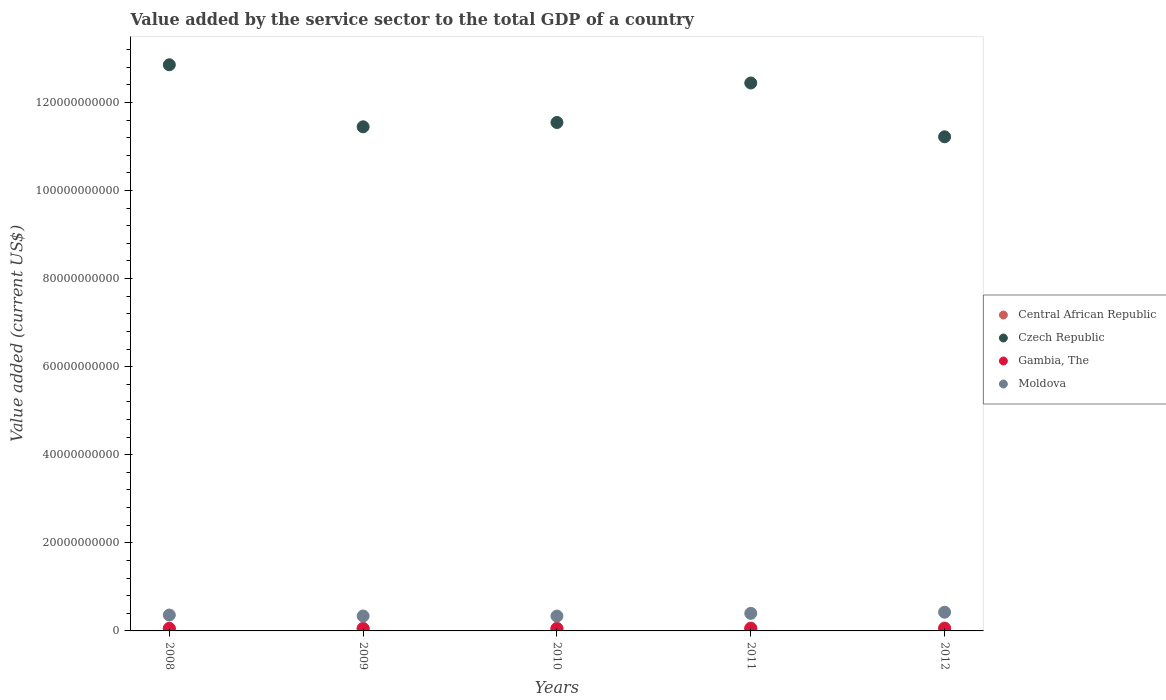How many different coloured dotlines are there?
Keep it short and to the point. 4. What is the value added by the service sector to the total GDP in Czech Republic in 2009?
Provide a short and direct response. 1.14e+11. Across all years, what is the maximum value added by the service sector to the total GDP in Czech Republic?
Give a very brief answer. 1.29e+11. Across all years, what is the minimum value added by the service sector to the total GDP in Czech Republic?
Your answer should be compact. 1.12e+11. In which year was the value added by the service sector to the total GDP in Central African Republic minimum?
Offer a very short reply. 2008. What is the total value added by the service sector to the total GDP in Gambia, The in the graph?
Offer a terse response. 2.60e+09. What is the difference between the value added by the service sector to the total GDP in Czech Republic in 2010 and that in 2012?
Keep it short and to the point. 3.25e+09. What is the difference between the value added by the service sector to the total GDP in Moldova in 2009 and the value added by the service sector to the total GDP in Central African Republic in 2008?
Ensure brevity in your answer.  2.81e+09. What is the average value added by the service sector to the total GDP in Czech Republic per year?
Provide a short and direct response. 1.19e+11. In the year 2011, what is the difference between the value added by the service sector to the total GDP in Gambia, The and value added by the service sector to the total GDP in Central African Republic?
Provide a succinct answer. -1.29e+08. In how many years, is the value added by the service sector to the total GDP in Central African Republic greater than 28000000000 US$?
Make the answer very short. 0. What is the ratio of the value added by the service sector to the total GDP in Central African Republic in 2008 to that in 2009?
Make the answer very short. 0.99. Is the difference between the value added by the service sector to the total GDP in Gambia, The in 2008 and 2009 greater than the difference between the value added by the service sector to the total GDP in Central African Republic in 2008 and 2009?
Make the answer very short. Yes. What is the difference between the highest and the second highest value added by the service sector to the total GDP in Gambia, The?
Give a very brief answer. 7.05e+06. What is the difference between the highest and the lowest value added by the service sector to the total GDP in Gambia, The?
Give a very brief answer. 4.17e+07. Is it the case that in every year, the sum of the value added by the service sector to the total GDP in Moldova and value added by the service sector to the total GDP in Gambia, The  is greater than the value added by the service sector to the total GDP in Czech Republic?
Make the answer very short. No. Is the value added by the service sector to the total GDP in Central African Republic strictly greater than the value added by the service sector to the total GDP in Moldova over the years?
Offer a very short reply. No. Is the value added by the service sector to the total GDP in Moldova strictly less than the value added by the service sector to the total GDP in Gambia, The over the years?
Ensure brevity in your answer.  No. How many dotlines are there?
Ensure brevity in your answer.  4. What is the difference between two consecutive major ticks on the Y-axis?
Ensure brevity in your answer.  2.00e+1. Where does the legend appear in the graph?
Make the answer very short. Center right. How many legend labels are there?
Your answer should be compact. 4. How are the legend labels stacked?
Your answer should be compact. Vertical. What is the title of the graph?
Offer a very short reply. Value added by the service sector to the total GDP of a country. What is the label or title of the Y-axis?
Keep it short and to the point. Value added (current US$). What is the Value added (current US$) in Central African Republic in 2008?
Ensure brevity in your answer.  5.79e+08. What is the Value added (current US$) of Czech Republic in 2008?
Make the answer very short. 1.29e+11. What is the Value added (current US$) in Gambia, The in 2008?
Offer a terse response. 5.37e+08. What is the Value added (current US$) of Moldova in 2008?
Your response must be concise. 3.61e+09. What is the Value added (current US$) of Central African Republic in 2009?
Offer a very short reply. 5.87e+08. What is the Value added (current US$) in Czech Republic in 2009?
Your answer should be compact. 1.14e+11. What is the Value added (current US$) of Gambia, The in 2009?
Offer a terse response. 4.95e+08. What is the Value added (current US$) in Moldova in 2009?
Offer a very short reply. 3.39e+09. What is the Value added (current US$) of Central African Republic in 2010?
Provide a succinct answer. 5.90e+08. What is the Value added (current US$) of Czech Republic in 2010?
Provide a succinct answer. 1.15e+11. What is the Value added (current US$) in Gambia, The in 2010?
Give a very brief answer. 5.06e+08. What is the Value added (current US$) in Moldova in 2010?
Provide a short and direct response. 3.37e+09. What is the Value added (current US$) in Central African Republic in 2011?
Give a very brief answer. 6.57e+08. What is the Value added (current US$) in Czech Republic in 2011?
Keep it short and to the point. 1.24e+11. What is the Value added (current US$) of Gambia, The in 2011?
Keep it short and to the point. 5.28e+08. What is the Value added (current US$) of Moldova in 2011?
Your answer should be compact. 3.98e+09. What is the Value added (current US$) of Central African Republic in 2012?
Your answer should be very brief. 6.59e+08. What is the Value added (current US$) of Czech Republic in 2012?
Make the answer very short. 1.12e+11. What is the Value added (current US$) of Gambia, The in 2012?
Give a very brief answer. 5.30e+08. What is the Value added (current US$) of Moldova in 2012?
Your answer should be compact. 4.25e+09. Across all years, what is the maximum Value added (current US$) in Central African Republic?
Offer a very short reply. 6.59e+08. Across all years, what is the maximum Value added (current US$) of Czech Republic?
Your answer should be compact. 1.29e+11. Across all years, what is the maximum Value added (current US$) of Gambia, The?
Provide a succinct answer. 5.37e+08. Across all years, what is the maximum Value added (current US$) in Moldova?
Keep it short and to the point. 4.25e+09. Across all years, what is the minimum Value added (current US$) in Central African Republic?
Offer a terse response. 5.79e+08. Across all years, what is the minimum Value added (current US$) in Czech Republic?
Provide a succinct answer. 1.12e+11. Across all years, what is the minimum Value added (current US$) in Gambia, The?
Ensure brevity in your answer.  4.95e+08. Across all years, what is the minimum Value added (current US$) in Moldova?
Your answer should be compact. 3.37e+09. What is the total Value added (current US$) of Central African Republic in the graph?
Provide a succinct answer. 3.07e+09. What is the total Value added (current US$) of Czech Republic in the graph?
Keep it short and to the point. 5.95e+11. What is the total Value added (current US$) in Gambia, The in the graph?
Your response must be concise. 2.60e+09. What is the total Value added (current US$) in Moldova in the graph?
Offer a very short reply. 1.86e+1. What is the difference between the Value added (current US$) of Central African Republic in 2008 and that in 2009?
Offer a very short reply. -7.69e+06. What is the difference between the Value added (current US$) of Czech Republic in 2008 and that in 2009?
Your answer should be compact. 1.41e+1. What is the difference between the Value added (current US$) in Gambia, The in 2008 and that in 2009?
Your answer should be very brief. 4.17e+07. What is the difference between the Value added (current US$) of Moldova in 2008 and that in 2009?
Provide a succinct answer. 2.19e+08. What is the difference between the Value added (current US$) in Central African Republic in 2008 and that in 2010?
Ensure brevity in your answer.  -1.05e+07. What is the difference between the Value added (current US$) in Czech Republic in 2008 and that in 2010?
Keep it short and to the point. 1.31e+1. What is the difference between the Value added (current US$) in Gambia, The in 2008 and that in 2010?
Give a very brief answer. 3.08e+07. What is the difference between the Value added (current US$) in Moldova in 2008 and that in 2010?
Your answer should be compact. 2.34e+08. What is the difference between the Value added (current US$) in Central African Republic in 2008 and that in 2011?
Offer a terse response. -7.82e+07. What is the difference between the Value added (current US$) in Czech Republic in 2008 and that in 2011?
Offer a terse response. 4.14e+09. What is the difference between the Value added (current US$) in Gambia, The in 2008 and that in 2011?
Provide a short and direct response. 8.90e+06. What is the difference between the Value added (current US$) in Moldova in 2008 and that in 2011?
Ensure brevity in your answer.  -3.77e+08. What is the difference between the Value added (current US$) of Central African Republic in 2008 and that in 2012?
Provide a short and direct response. -7.96e+07. What is the difference between the Value added (current US$) in Czech Republic in 2008 and that in 2012?
Your response must be concise. 1.64e+1. What is the difference between the Value added (current US$) in Gambia, The in 2008 and that in 2012?
Your answer should be very brief. 7.05e+06. What is the difference between the Value added (current US$) of Moldova in 2008 and that in 2012?
Give a very brief answer. -6.42e+08. What is the difference between the Value added (current US$) of Central African Republic in 2009 and that in 2010?
Provide a short and direct response. -2.83e+06. What is the difference between the Value added (current US$) in Czech Republic in 2009 and that in 2010?
Ensure brevity in your answer.  -9.76e+08. What is the difference between the Value added (current US$) of Gambia, The in 2009 and that in 2010?
Provide a succinct answer. -1.09e+07. What is the difference between the Value added (current US$) in Moldova in 2009 and that in 2010?
Your answer should be very brief. 1.49e+07. What is the difference between the Value added (current US$) in Central African Republic in 2009 and that in 2011?
Keep it short and to the point. -7.05e+07. What is the difference between the Value added (current US$) of Czech Republic in 2009 and that in 2011?
Your answer should be compact. -9.95e+09. What is the difference between the Value added (current US$) of Gambia, The in 2009 and that in 2011?
Make the answer very short. -3.28e+07. What is the difference between the Value added (current US$) in Moldova in 2009 and that in 2011?
Provide a succinct answer. -5.96e+08. What is the difference between the Value added (current US$) in Central African Republic in 2009 and that in 2012?
Offer a very short reply. -7.19e+07. What is the difference between the Value added (current US$) in Czech Republic in 2009 and that in 2012?
Make the answer very short. 2.27e+09. What is the difference between the Value added (current US$) of Gambia, The in 2009 and that in 2012?
Your response must be concise. -3.47e+07. What is the difference between the Value added (current US$) of Moldova in 2009 and that in 2012?
Your response must be concise. -8.62e+08. What is the difference between the Value added (current US$) of Central African Republic in 2010 and that in 2011?
Offer a terse response. -6.77e+07. What is the difference between the Value added (current US$) of Czech Republic in 2010 and that in 2011?
Provide a succinct answer. -8.97e+09. What is the difference between the Value added (current US$) in Gambia, The in 2010 and that in 2011?
Provide a short and direct response. -2.19e+07. What is the difference between the Value added (current US$) in Moldova in 2010 and that in 2011?
Provide a succinct answer. -6.11e+08. What is the difference between the Value added (current US$) in Central African Republic in 2010 and that in 2012?
Keep it short and to the point. -6.91e+07. What is the difference between the Value added (current US$) in Czech Republic in 2010 and that in 2012?
Make the answer very short. 3.25e+09. What is the difference between the Value added (current US$) of Gambia, The in 2010 and that in 2012?
Make the answer very short. -2.37e+07. What is the difference between the Value added (current US$) of Moldova in 2010 and that in 2012?
Your answer should be compact. -8.77e+08. What is the difference between the Value added (current US$) in Central African Republic in 2011 and that in 2012?
Offer a very short reply. -1.39e+06. What is the difference between the Value added (current US$) in Czech Republic in 2011 and that in 2012?
Your answer should be very brief. 1.22e+1. What is the difference between the Value added (current US$) in Gambia, The in 2011 and that in 2012?
Your answer should be compact. -1.85e+06. What is the difference between the Value added (current US$) in Moldova in 2011 and that in 2012?
Ensure brevity in your answer.  -2.65e+08. What is the difference between the Value added (current US$) of Central African Republic in 2008 and the Value added (current US$) of Czech Republic in 2009?
Offer a very short reply. -1.14e+11. What is the difference between the Value added (current US$) of Central African Republic in 2008 and the Value added (current US$) of Gambia, The in 2009?
Keep it short and to the point. 8.40e+07. What is the difference between the Value added (current US$) in Central African Republic in 2008 and the Value added (current US$) in Moldova in 2009?
Keep it short and to the point. -2.81e+09. What is the difference between the Value added (current US$) in Czech Republic in 2008 and the Value added (current US$) in Gambia, The in 2009?
Provide a short and direct response. 1.28e+11. What is the difference between the Value added (current US$) of Czech Republic in 2008 and the Value added (current US$) of Moldova in 2009?
Provide a short and direct response. 1.25e+11. What is the difference between the Value added (current US$) in Gambia, The in 2008 and the Value added (current US$) in Moldova in 2009?
Provide a short and direct response. -2.85e+09. What is the difference between the Value added (current US$) of Central African Republic in 2008 and the Value added (current US$) of Czech Republic in 2010?
Provide a succinct answer. -1.15e+11. What is the difference between the Value added (current US$) in Central African Republic in 2008 and the Value added (current US$) in Gambia, The in 2010?
Your answer should be compact. 7.31e+07. What is the difference between the Value added (current US$) of Central African Republic in 2008 and the Value added (current US$) of Moldova in 2010?
Make the answer very short. -2.79e+09. What is the difference between the Value added (current US$) in Czech Republic in 2008 and the Value added (current US$) in Gambia, The in 2010?
Ensure brevity in your answer.  1.28e+11. What is the difference between the Value added (current US$) in Czech Republic in 2008 and the Value added (current US$) in Moldova in 2010?
Your answer should be compact. 1.25e+11. What is the difference between the Value added (current US$) in Gambia, The in 2008 and the Value added (current US$) in Moldova in 2010?
Your response must be concise. -2.84e+09. What is the difference between the Value added (current US$) of Central African Republic in 2008 and the Value added (current US$) of Czech Republic in 2011?
Offer a very short reply. -1.24e+11. What is the difference between the Value added (current US$) in Central African Republic in 2008 and the Value added (current US$) in Gambia, The in 2011?
Offer a very short reply. 5.12e+07. What is the difference between the Value added (current US$) of Central African Republic in 2008 and the Value added (current US$) of Moldova in 2011?
Give a very brief answer. -3.41e+09. What is the difference between the Value added (current US$) of Czech Republic in 2008 and the Value added (current US$) of Gambia, The in 2011?
Keep it short and to the point. 1.28e+11. What is the difference between the Value added (current US$) of Czech Republic in 2008 and the Value added (current US$) of Moldova in 2011?
Offer a terse response. 1.25e+11. What is the difference between the Value added (current US$) of Gambia, The in 2008 and the Value added (current US$) of Moldova in 2011?
Keep it short and to the point. -3.45e+09. What is the difference between the Value added (current US$) in Central African Republic in 2008 and the Value added (current US$) in Czech Republic in 2012?
Your answer should be very brief. -1.12e+11. What is the difference between the Value added (current US$) of Central African Republic in 2008 and the Value added (current US$) of Gambia, The in 2012?
Your answer should be compact. 4.93e+07. What is the difference between the Value added (current US$) of Central African Republic in 2008 and the Value added (current US$) of Moldova in 2012?
Ensure brevity in your answer.  -3.67e+09. What is the difference between the Value added (current US$) in Czech Republic in 2008 and the Value added (current US$) in Gambia, The in 2012?
Make the answer very short. 1.28e+11. What is the difference between the Value added (current US$) in Czech Republic in 2008 and the Value added (current US$) in Moldova in 2012?
Provide a succinct answer. 1.24e+11. What is the difference between the Value added (current US$) in Gambia, The in 2008 and the Value added (current US$) in Moldova in 2012?
Give a very brief answer. -3.71e+09. What is the difference between the Value added (current US$) of Central African Republic in 2009 and the Value added (current US$) of Czech Republic in 2010?
Ensure brevity in your answer.  -1.15e+11. What is the difference between the Value added (current US$) of Central African Republic in 2009 and the Value added (current US$) of Gambia, The in 2010?
Your response must be concise. 8.08e+07. What is the difference between the Value added (current US$) in Central African Republic in 2009 and the Value added (current US$) in Moldova in 2010?
Provide a succinct answer. -2.79e+09. What is the difference between the Value added (current US$) of Czech Republic in 2009 and the Value added (current US$) of Gambia, The in 2010?
Offer a very short reply. 1.14e+11. What is the difference between the Value added (current US$) of Czech Republic in 2009 and the Value added (current US$) of Moldova in 2010?
Ensure brevity in your answer.  1.11e+11. What is the difference between the Value added (current US$) of Gambia, The in 2009 and the Value added (current US$) of Moldova in 2010?
Keep it short and to the point. -2.88e+09. What is the difference between the Value added (current US$) of Central African Republic in 2009 and the Value added (current US$) of Czech Republic in 2011?
Ensure brevity in your answer.  -1.24e+11. What is the difference between the Value added (current US$) in Central African Republic in 2009 and the Value added (current US$) in Gambia, The in 2011?
Offer a very short reply. 5.89e+07. What is the difference between the Value added (current US$) in Central African Republic in 2009 and the Value added (current US$) in Moldova in 2011?
Make the answer very short. -3.40e+09. What is the difference between the Value added (current US$) in Czech Republic in 2009 and the Value added (current US$) in Gambia, The in 2011?
Provide a succinct answer. 1.14e+11. What is the difference between the Value added (current US$) of Czech Republic in 2009 and the Value added (current US$) of Moldova in 2011?
Your response must be concise. 1.10e+11. What is the difference between the Value added (current US$) of Gambia, The in 2009 and the Value added (current US$) of Moldova in 2011?
Offer a very short reply. -3.49e+09. What is the difference between the Value added (current US$) in Central African Republic in 2009 and the Value added (current US$) in Czech Republic in 2012?
Provide a succinct answer. -1.12e+11. What is the difference between the Value added (current US$) of Central African Republic in 2009 and the Value added (current US$) of Gambia, The in 2012?
Provide a succinct answer. 5.70e+07. What is the difference between the Value added (current US$) in Central African Republic in 2009 and the Value added (current US$) in Moldova in 2012?
Provide a short and direct response. -3.66e+09. What is the difference between the Value added (current US$) of Czech Republic in 2009 and the Value added (current US$) of Gambia, The in 2012?
Ensure brevity in your answer.  1.14e+11. What is the difference between the Value added (current US$) in Czech Republic in 2009 and the Value added (current US$) in Moldova in 2012?
Ensure brevity in your answer.  1.10e+11. What is the difference between the Value added (current US$) in Gambia, The in 2009 and the Value added (current US$) in Moldova in 2012?
Provide a short and direct response. -3.76e+09. What is the difference between the Value added (current US$) of Central African Republic in 2010 and the Value added (current US$) of Czech Republic in 2011?
Make the answer very short. -1.24e+11. What is the difference between the Value added (current US$) of Central African Republic in 2010 and the Value added (current US$) of Gambia, The in 2011?
Your answer should be compact. 6.17e+07. What is the difference between the Value added (current US$) in Central African Republic in 2010 and the Value added (current US$) in Moldova in 2011?
Offer a terse response. -3.40e+09. What is the difference between the Value added (current US$) in Czech Republic in 2010 and the Value added (current US$) in Gambia, The in 2011?
Your response must be concise. 1.15e+11. What is the difference between the Value added (current US$) in Czech Republic in 2010 and the Value added (current US$) in Moldova in 2011?
Your answer should be compact. 1.11e+11. What is the difference between the Value added (current US$) in Gambia, The in 2010 and the Value added (current US$) in Moldova in 2011?
Make the answer very short. -3.48e+09. What is the difference between the Value added (current US$) in Central African Republic in 2010 and the Value added (current US$) in Czech Republic in 2012?
Your answer should be compact. -1.12e+11. What is the difference between the Value added (current US$) of Central African Republic in 2010 and the Value added (current US$) of Gambia, The in 2012?
Your answer should be very brief. 5.99e+07. What is the difference between the Value added (current US$) in Central African Republic in 2010 and the Value added (current US$) in Moldova in 2012?
Provide a succinct answer. -3.66e+09. What is the difference between the Value added (current US$) of Czech Republic in 2010 and the Value added (current US$) of Gambia, The in 2012?
Make the answer very short. 1.15e+11. What is the difference between the Value added (current US$) in Czech Republic in 2010 and the Value added (current US$) in Moldova in 2012?
Your response must be concise. 1.11e+11. What is the difference between the Value added (current US$) in Gambia, The in 2010 and the Value added (current US$) in Moldova in 2012?
Offer a very short reply. -3.74e+09. What is the difference between the Value added (current US$) of Central African Republic in 2011 and the Value added (current US$) of Czech Republic in 2012?
Make the answer very short. -1.12e+11. What is the difference between the Value added (current US$) in Central African Republic in 2011 and the Value added (current US$) in Gambia, The in 2012?
Provide a short and direct response. 1.28e+08. What is the difference between the Value added (current US$) in Central African Republic in 2011 and the Value added (current US$) in Moldova in 2012?
Provide a short and direct response. -3.59e+09. What is the difference between the Value added (current US$) in Czech Republic in 2011 and the Value added (current US$) in Gambia, The in 2012?
Offer a terse response. 1.24e+11. What is the difference between the Value added (current US$) of Czech Republic in 2011 and the Value added (current US$) of Moldova in 2012?
Ensure brevity in your answer.  1.20e+11. What is the difference between the Value added (current US$) of Gambia, The in 2011 and the Value added (current US$) of Moldova in 2012?
Ensure brevity in your answer.  -3.72e+09. What is the average Value added (current US$) in Central African Republic per year?
Offer a very short reply. 6.14e+08. What is the average Value added (current US$) in Czech Republic per year?
Your response must be concise. 1.19e+11. What is the average Value added (current US$) of Gambia, The per year?
Ensure brevity in your answer.  5.19e+08. What is the average Value added (current US$) of Moldova per year?
Offer a very short reply. 3.72e+09. In the year 2008, what is the difference between the Value added (current US$) of Central African Republic and Value added (current US$) of Czech Republic?
Your answer should be compact. -1.28e+11. In the year 2008, what is the difference between the Value added (current US$) of Central African Republic and Value added (current US$) of Gambia, The?
Provide a short and direct response. 4.23e+07. In the year 2008, what is the difference between the Value added (current US$) of Central African Republic and Value added (current US$) of Moldova?
Provide a short and direct response. -3.03e+09. In the year 2008, what is the difference between the Value added (current US$) in Czech Republic and Value added (current US$) in Gambia, The?
Make the answer very short. 1.28e+11. In the year 2008, what is the difference between the Value added (current US$) of Czech Republic and Value added (current US$) of Moldova?
Offer a very short reply. 1.25e+11. In the year 2008, what is the difference between the Value added (current US$) of Gambia, The and Value added (current US$) of Moldova?
Provide a succinct answer. -3.07e+09. In the year 2009, what is the difference between the Value added (current US$) in Central African Republic and Value added (current US$) in Czech Republic?
Provide a succinct answer. -1.14e+11. In the year 2009, what is the difference between the Value added (current US$) of Central African Republic and Value added (current US$) of Gambia, The?
Your answer should be compact. 9.17e+07. In the year 2009, what is the difference between the Value added (current US$) of Central African Republic and Value added (current US$) of Moldova?
Your answer should be compact. -2.80e+09. In the year 2009, what is the difference between the Value added (current US$) of Czech Republic and Value added (current US$) of Gambia, The?
Provide a succinct answer. 1.14e+11. In the year 2009, what is the difference between the Value added (current US$) of Czech Republic and Value added (current US$) of Moldova?
Your answer should be compact. 1.11e+11. In the year 2009, what is the difference between the Value added (current US$) in Gambia, The and Value added (current US$) in Moldova?
Your answer should be compact. -2.89e+09. In the year 2010, what is the difference between the Value added (current US$) of Central African Republic and Value added (current US$) of Czech Republic?
Your response must be concise. -1.15e+11. In the year 2010, what is the difference between the Value added (current US$) in Central African Republic and Value added (current US$) in Gambia, The?
Provide a succinct answer. 8.36e+07. In the year 2010, what is the difference between the Value added (current US$) in Central African Republic and Value added (current US$) in Moldova?
Your response must be concise. -2.78e+09. In the year 2010, what is the difference between the Value added (current US$) of Czech Republic and Value added (current US$) of Gambia, The?
Your answer should be compact. 1.15e+11. In the year 2010, what is the difference between the Value added (current US$) in Czech Republic and Value added (current US$) in Moldova?
Give a very brief answer. 1.12e+11. In the year 2010, what is the difference between the Value added (current US$) of Gambia, The and Value added (current US$) of Moldova?
Provide a short and direct response. -2.87e+09. In the year 2011, what is the difference between the Value added (current US$) in Central African Republic and Value added (current US$) in Czech Republic?
Ensure brevity in your answer.  -1.24e+11. In the year 2011, what is the difference between the Value added (current US$) in Central African Republic and Value added (current US$) in Gambia, The?
Ensure brevity in your answer.  1.29e+08. In the year 2011, what is the difference between the Value added (current US$) of Central African Republic and Value added (current US$) of Moldova?
Your answer should be very brief. -3.33e+09. In the year 2011, what is the difference between the Value added (current US$) of Czech Republic and Value added (current US$) of Gambia, The?
Provide a short and direct response. 1.24e+11. In the year 2011, what is the difference between the Value added (current US$) in Czech Republic and Value added (current US$) in Moldova?
Keep it short and to the point. 1.20e+11. In the year 2011, what is the difference between the Value added (current US$) in Gambia, The and Value added (current US$) in Moldova?
Provide a succinct answer. -3.46e+09. In the year 2012, what is the difference between the Value added (current US$) of Central African Republic and Value added (current US$) of Czech Republic?
Give a very brief answer. -1.12e+11. In the year 2012, what is the difference between the Value added (current US$) of Central African Republic and Value added (current US$) of Gambia, The?
Make the answer very short. 1.29e+08. In the year 2012, what is the difference between the Value added (current US$) in Central African Republic and Value added (current US$) in Moldova?
Ensure brevity in your answer.  -3.59e+09. In the year 2012, what is the difference between the Value added (current US$) in Czech Republic and Value added (current US$) in Gambia, The?
Provide a short and direct response. 1.12e+11. In the year 2012, what is the difference between the Value added (current US$) in Czech Republic and Value added (current US$) in Moldova?
Your answer should be compact. 1.08e+11. In the year 2012, what is the difference between the Value added (current US$) of Gambia, The and Value added (current US$) of Moldova?
Keep it short and to the point. -3.72e+09. What is the ratio of the Value added (current US$) in Central African Republic in 2008 to that in 2009?
Provide a short and direct response. 0.99. What is the ratio of the Value added (current US$) of Czech Republic in 2008 to that in 2009?
Your response must be concise. 1.12. What is the ratio of the Value added (current US$) in Gambia, The in 2008 to that in 2009?
Ensure brevity in your answer.  1.08. What is the ratio of the Value added (current US$) in Moldova in 2008 to that in 2009?
Ensure brevity in your answer.  1.06. What is the ratio of the Value added (current US$) of Central African Republic in 2008 to that in 2010?
Your response must be concise. 0.98. What is the ratio of the Value added (current US$) in Czech Republic in 2008 to that in 2010?
Make the answer very short. 1.11. What is the ratio of the Value added (current US$) of Gambia, The in 2008 to that in 2010?
Make the answer very short. 1.06. What is the ratio of the Value added (current US$) in Moldova in 2008 to that in 2010?
Provide a short and direct response. 1.07. What is the ratio of the Value added (current US$) in Central African Republic in 2008 to that in 2011?
Offer a terse response. 0.88. What is the ratio of the Value added (current US$) of Czech Republic in 2008 to that in 2011?
Provide a short and direct response. 1.03. What is the ratio of the Value added (current US$) of Gambia, The in 2008 to that in 2011?
Make the answer very short. 1.02. What is the ratio of the Value added (current US$) in Moldova in 2008 to that in 2011?
Your answer should be very brief. 0.91. What is the ratio of the Value added (current US$) of Central African Republic in 2008 to that in 2012?
Your answer should be very brief. 0.88. What is the ratio of the Value added (current US$) in Czech Republic in 2008 to that in 2012?
Keep it short and to the point. 1.15. What is the ratio of the Value added (current US$) of Gambia, The in 2008 to that in 2012?
Keep it short and to the point. 1.01. What is the ratio of the Value added (current US$) in Moldova in 2008 to that in 2012?
Make the answer very short. 0.85. What is the ratio of the Value added (current US$) of Gambia, The in 2009 to that in 2010?
Your response must be concise. 0.98. What is the ratio of the Value added (current US$) in Central African Republic in 2009 to that in 2011?
Your response must be concise. 0.89. What is the ratio of the Value added (current US$) of Czech Republic in 2009 to that in 2011?
Provide a succinct answer. 0.92. What is the ratio of the Value added (current US$) in Gambia, The in 2009 to that in 2011?
Your answer should be very brief. 0.94. What is the ratio of the Value added (current US$) in Moldova in 2009 to that in 2011?
Your response must be concise. 0.85. What is the ratio of the Value added (current US$) of Central African Republic in 2009 to that in 2012?
Your response must be concise. 0.89. What is the ratio of the Value added (current US$) in Czech Republic in 2009 to that in 2012?
Provide a succinct answer. 1.02. What is the ratio of the Value added (current US$) in Gambia, The in 2009 to that in 2012?
Provide a short and direct response. 0.93. What is the ratio of the Value added (current US$) in Moldova in 2009 to that in 2012?
Keep it short and to the point. 0.8. What is the ratio of the Value added (current US$) in Central African Republic in 2010 to that in 2011?
Offer a terse response. 0.9. What is the ratio of the Value added (current US$) of Czech Republic in 2010 to that in 2011?
Offer a very short reply. 0.93. What is the ratio of the Value added (current US$) of Gambia, The in 2010 to that in 2011?
Keep it short and to the point. 0.96. What is the ratio of the Value added (current US$) of Moldova in 2010 to that in 2011?
Ensure brevity in your answer.  0.85. What is the ratio of the Value added (current US$) of Central African Republic in 2010 to that in 2012?
Provide a short and direct response. 0.9. What is the ratio of the Value added (current US$) in Czech Republic in 2010 to that in 2012?
Your answer should be compact. 1.03. What is the ratio of the Value added (current US$) of Gambia, The in 2010 to that in 2012?
Keep it short and to the point. 0.96. What is the ratio of the Value added (current US$) in Moldova in 2010 to that in 2012?
Give a very brief answer. 0.79. What is the ratio of the Value added (current US$) of Central African Republic in 2011 to that in 2012?
Give a very brief answer. 1. What is the ratio of the Value added (current US$) in Czech Republic in 2011 to that in 2012?
Provide a succinct answer. 1.11. What is the ratio of the Value added (current US$) of Gambia, The in 2011 to that in 2012?
Give a very brief answer. 1. What is the ratio of the Value added (current US$) of Moldova in 2011 to that in 2012?
Make the answer very short. 0.94. What is the difference between the highest and the second highest Value added (current US$) in Central African Republic?
Your answer should be very brief. 1.39e+06. What is the difference between the highest and the second highest Value added (current US$) of Czech Republic?
Your answer should be very brief. 4.14e+09. What is the difference between the highest and the second highest Value added (current US$) of Gambia, The?
Your response must be concise. 7.05e+06. What is the difference between the highest and the second highest Value added (current US$) in Moldova?
Offer a terse response. 2.65e+08. What is the difference between the highest and the lowest Value added (current US$) of Central African Republic?
Provide a short and direct response. 7.96e+07. What is the difference between the highest and the lowest Value added (current US$) in Czech Republic?
Make the answer very short. 1.64e+1. What is the difference between the highest and the lowest Value added (current US$) in Gambia, The?
Your answer should be very brief. 4.17e+07. What is the difference between the highest and the lowest Value added (current US$) in Moldova?
Offer a very short reply. 8.77e+08. 